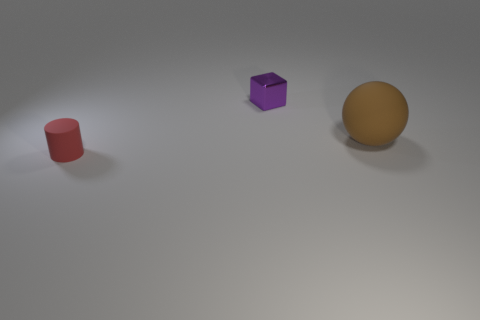Add 1 cyan rubber blocks. How many objects exist? 4 Subtract all cylinders. How many objects are left? 2 Add 3 cylinders. How many cylinders are left? 4 Add 2 big brown rubber objects. How many big brown rubber objects exist? 3 Subtract 0 yellow cubes. How many objects are left? 3 Subtract all large green metal cylinders. Subtract all small red rubber cylinders. How many objects are left? 2 